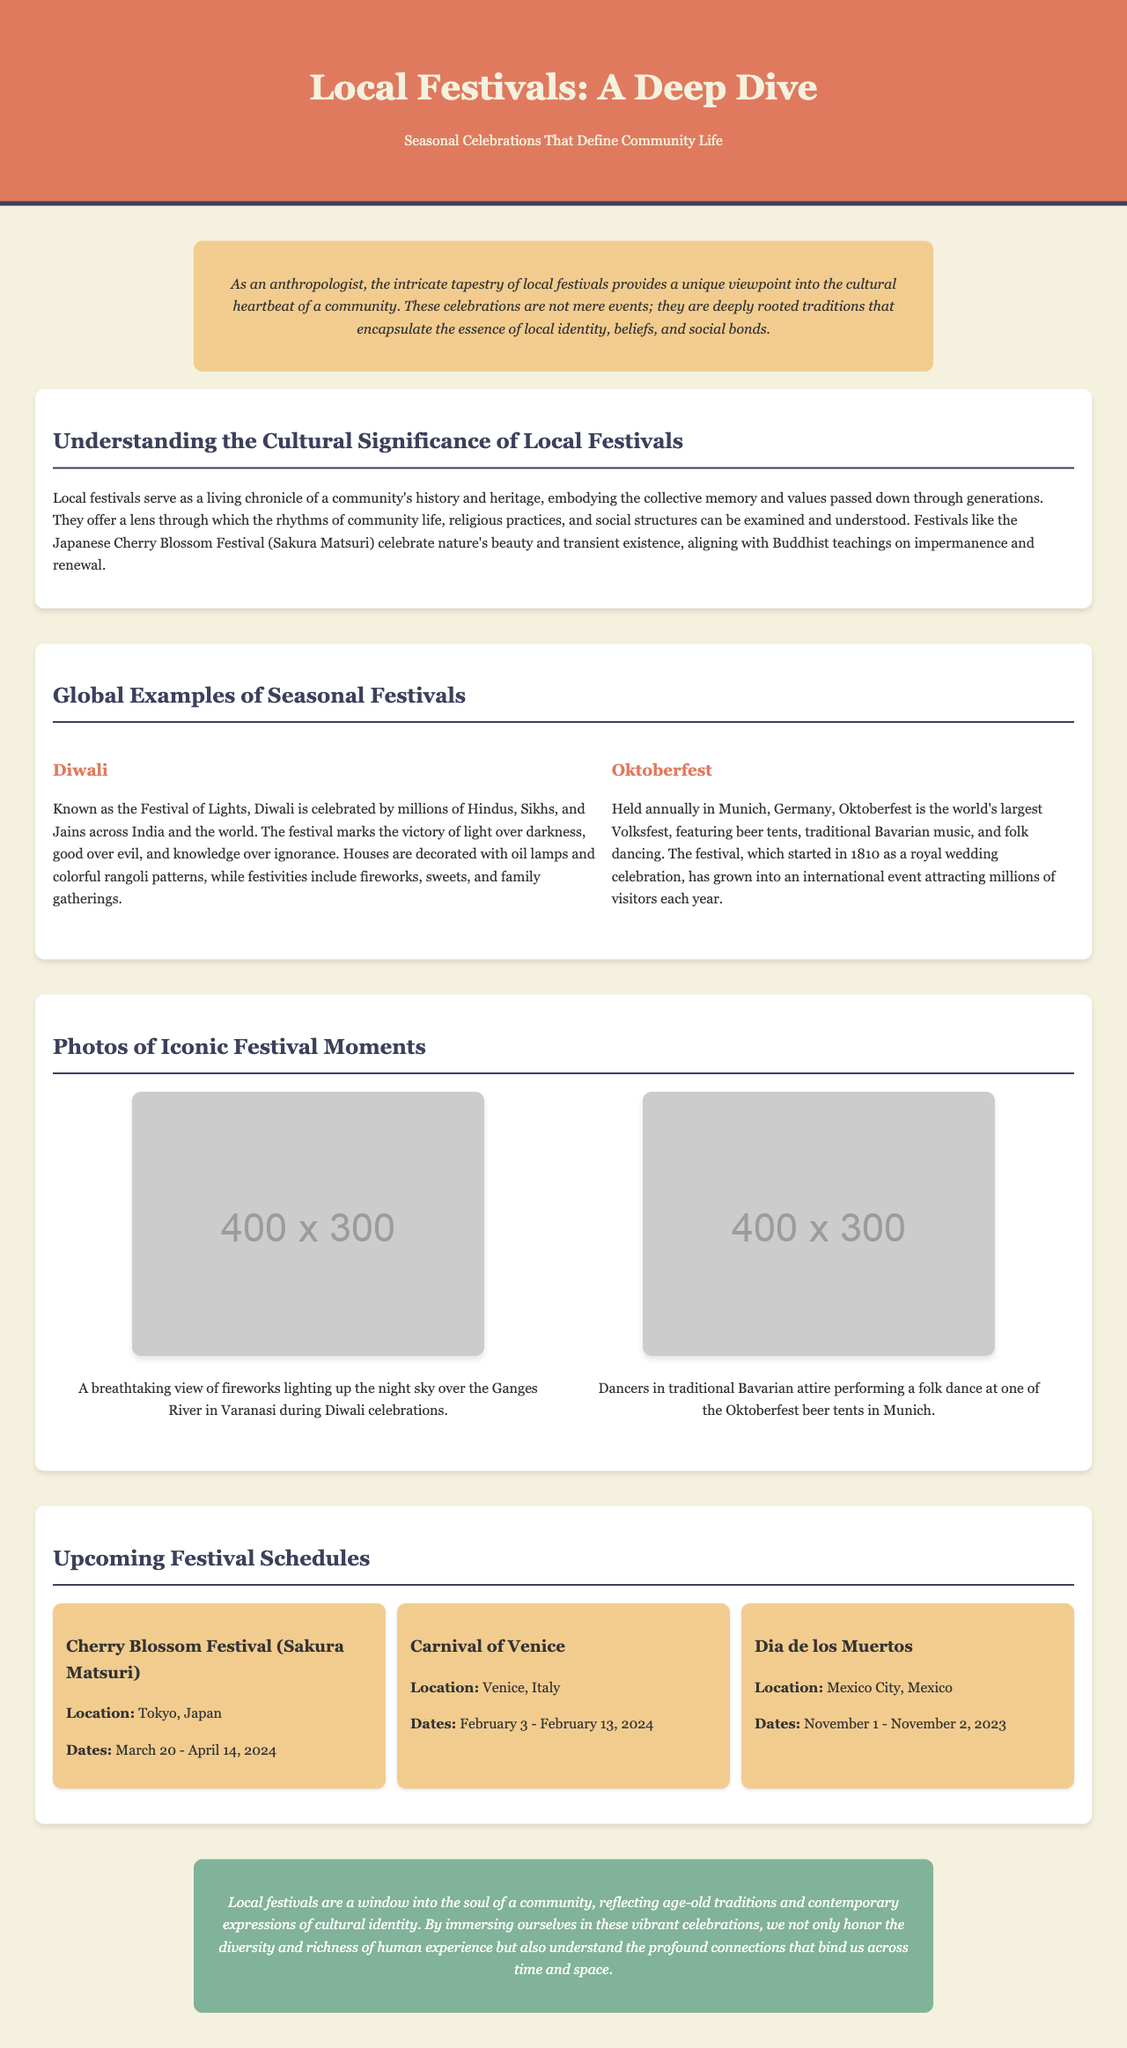What is the title of the document? The title of the document is prominently displayed in the header section.
Answer: Local Festivals: A Deep Dive What is the introductory message about festivals? The introductory message captures the essence of festivals as culturally significant events that define community life.
Answer: A unique viewpoint into the cultural heartbeat of a community What festival is celebrated as the Festival of Lights? The document provides specific names and descriptions of various festivals, including this one.
Answer: Diwali Where does the Cherry Blossom Festival take place? The location of this festival is explicitly mentioned in the upcoming festival schedules section.
Answer: Tokyo, Japan What are the dates for Dia de los Muertos? The specific dates for this festival are highlighted in the upcoming festival schedules section.
Answer: November 1 - November 2, 2023 What cultural aspect does the Cherry Blossom Festival reflect? The text discusses various cultural themes tied to festivals, relating them to beliefs and social identity.
Answer: Nature's beauty and transient existence How many photos are included in the document? The document section dedicated to iconic festival moments includes two photos.
Answer: Two What color is used for the header background? The document specifies the color used in the header, contributing to its visual identity.
Answer: #e07a5f Which festival originated from a royal wedding celebration? The document describes the origins of different festivals, focusing on this one specifically.
Answer: Oktoberfest 